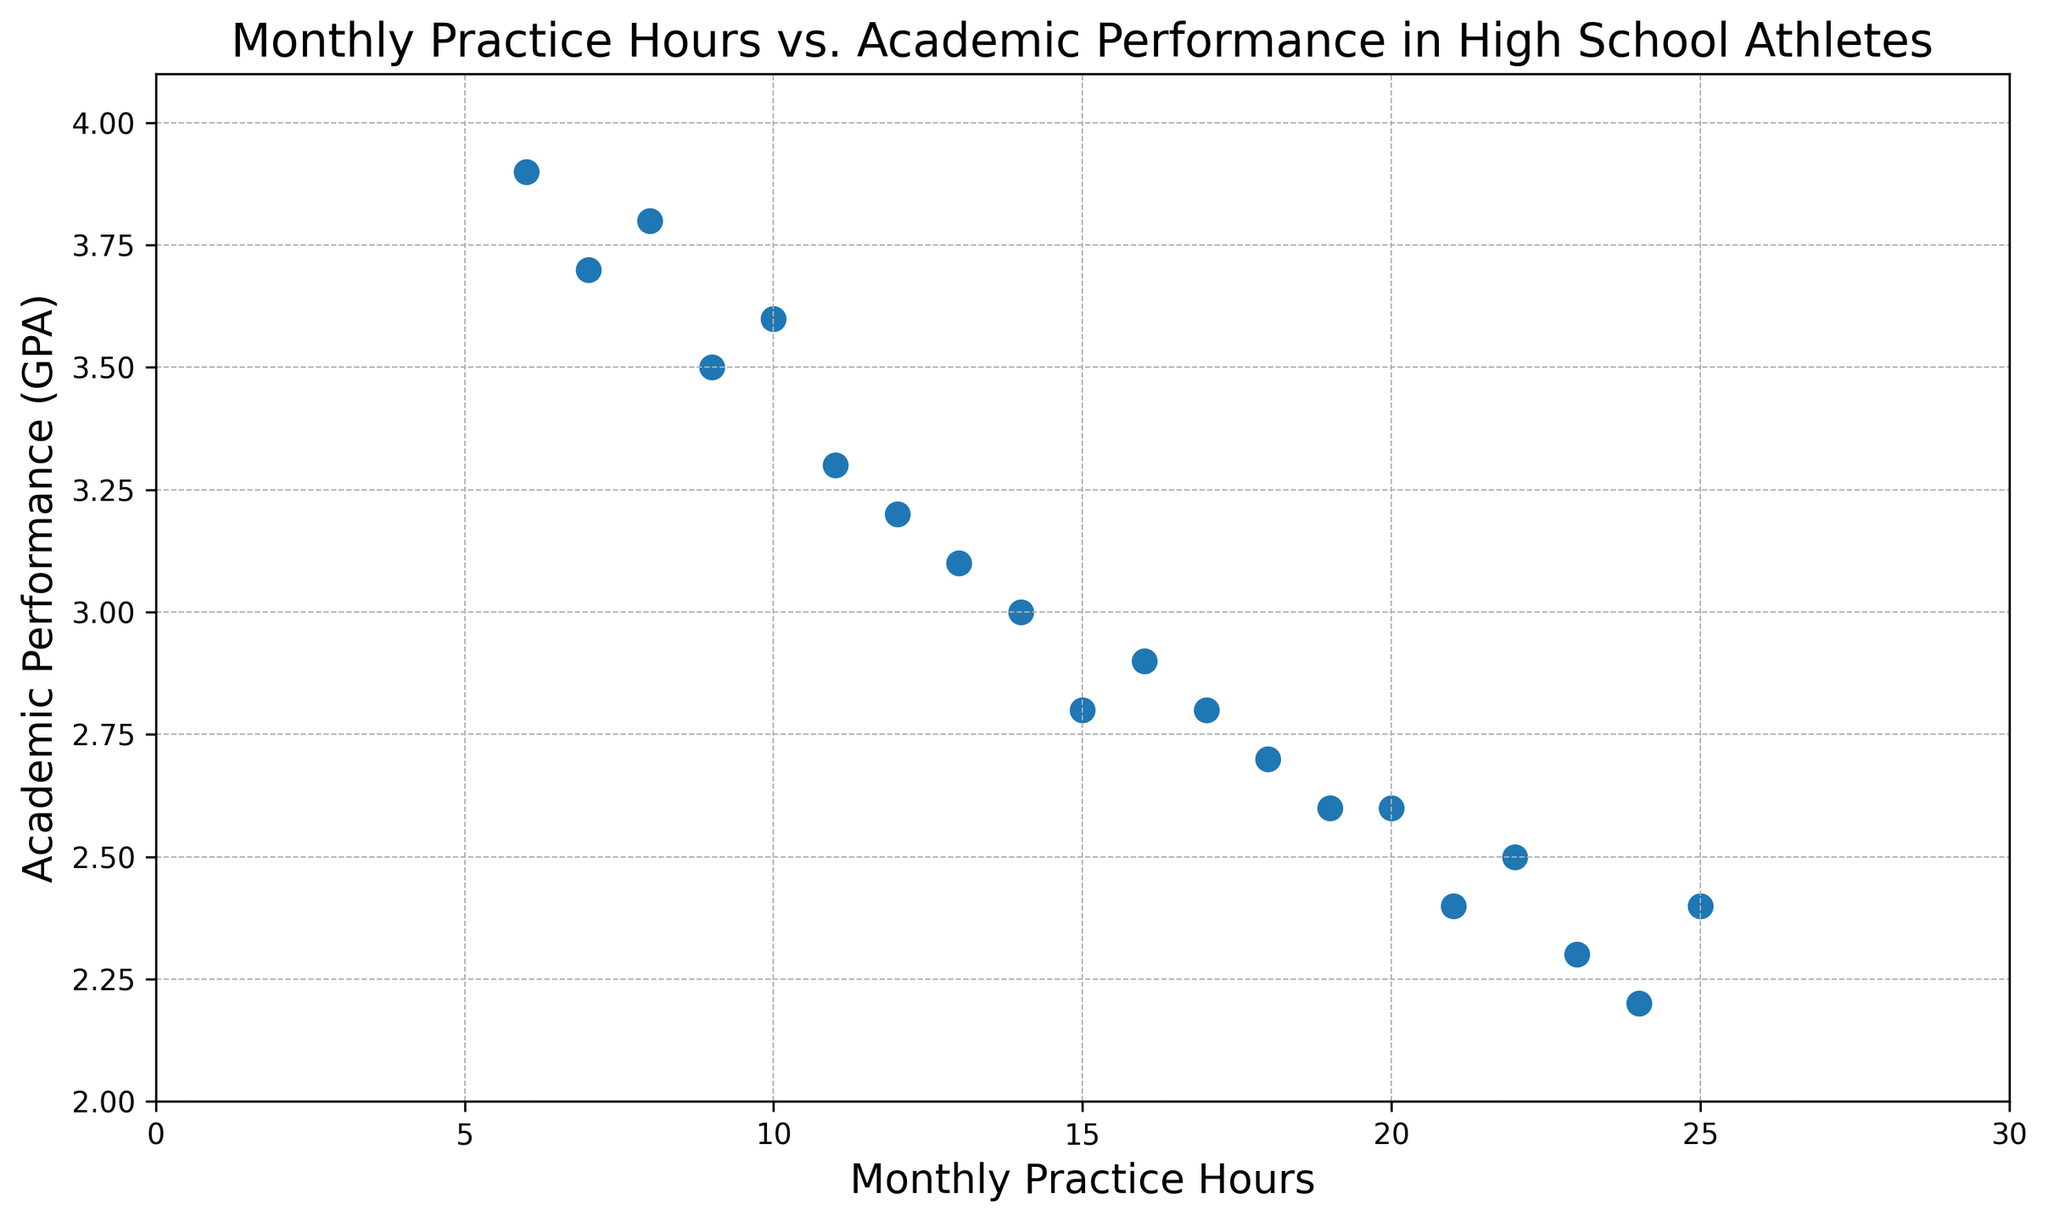How many students have a GPA above 3.0? First, count the number of data points where the GPA (Academic Performance) is greater than 3.0. From the data, these students have Academic Performance values of 3.2, 3.6, 3.8, 3.3, 3.5, 3.7, and 3.9.
Answer: 7 What is the average practice hours among students with a GPA below 3.0? Identify the data points where the GPA is below 3.0 (2.8, 2.7, 2.5, 2.4, 3.0, 2.6, 2.3, 2.2). Sum the practice hours for these students: 15, 18, 22, 25, 14, 20, 23, 24, then divide by the number of these students, which is 8. (15+18+22+25+14+20+23+24)/8 = 161/8
Answer: 20.125 Which students practice the most and least, respectively, and what are their GPAs? The most practice hours is 25, corresponding to a GPA of 2.4, and the least practice hours are 6, corresponding to a GPA of 3.9.
Answer: Most: GPA 2.4, Least: GPA 3.9 Is there a visible trend between practice hours and GPA in the plot? Observing the scatter plot, as practice hours increase, GPA tends to decrease, indicating a negative relationship.
Answer: Negative trend What is the range of practice hours depicted in the plot? Identify the minimum and maximum practice hours in the data, which are 6 and 25 respectively. The range is the difference between the maximum and minimum values. Range = 25 - 6
Answer: 19 Are there any students with the same practice hours but different GPAs? Look for any repeated practice hours in the plot with different corresponding GPA values. There are no students with the same practice hours observed in the given data range.
Answer: No How many students practice more than 20 hours a month? Identify and count data points where the practice hours are greater than 20. These values are 22, 25, 23, 21, 24.
Answer: 5 